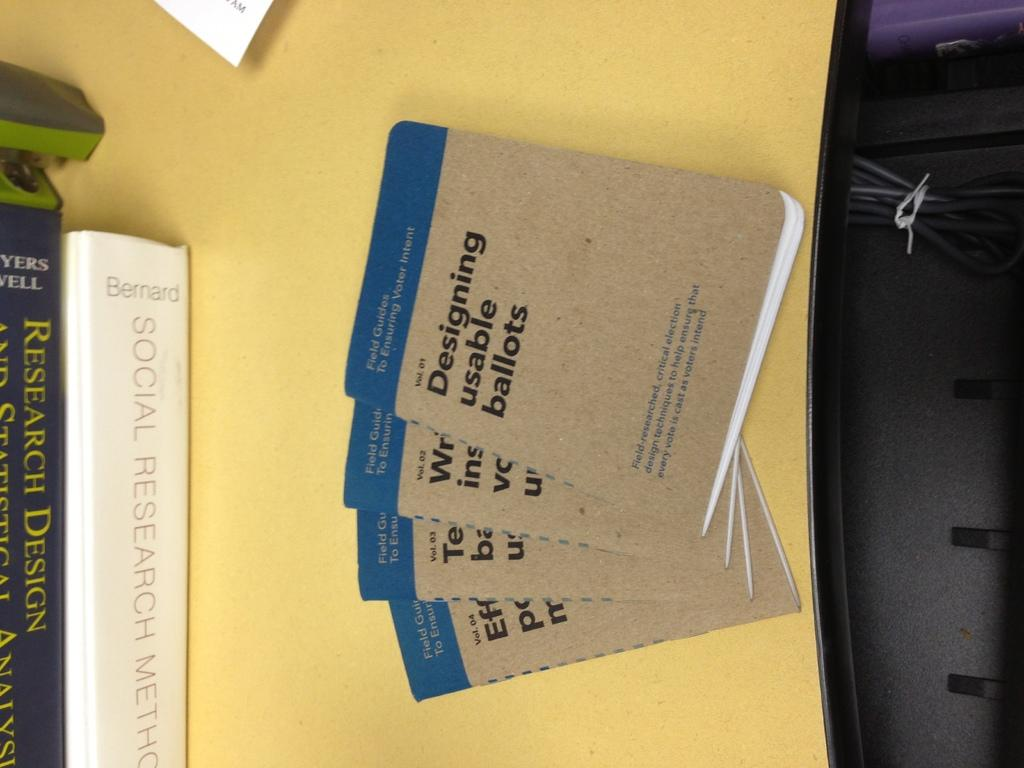<image>
Render a clear and concise summary of the photo. A stack of books titled Designing usable ballots are laying on a yellow table. 